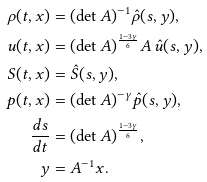<formula> <loc_0><loc_0><loc_500><loc_500>\rho ( t , x ) & = ( \det A ) ^ { - 1 } \hat { \rho } ( s , y ) , \\ u ( t , x ) & = ( \det A ) ^ { \frac { 1 - 3 \gamma } { 6 } } A \, \hat { u } ( s , y ) , \\ S ( t , x ) & = \hat { S } ( s , y ) , \\ p ( t , x ) & = ( \det A ) ^ { - \gamma } \hat { p } ( s , y ) , \\ \frac { d s } { d t } & = ( \det A ) ^ { \frac { 1 - 3 \gamma } { 6 } } , \\ y & = A ^ { - 1 } x .</formula> 